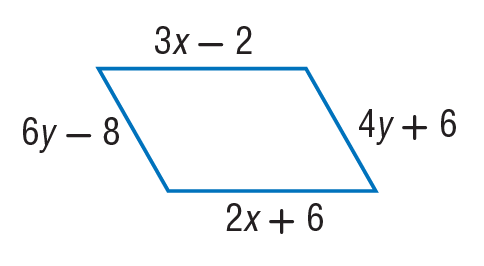Question: Find x so that the quadrilateral is a parallelogram.
Choices:
A. 8
B. 22
C. 24
D. 40
Answer with the letter. Answer: A Question: Find y so that the quadrilateral is a parallelogram.
Choices:
A. 7
B. 19
C. 25
D. 55
Answer with the letter. Answer: A 